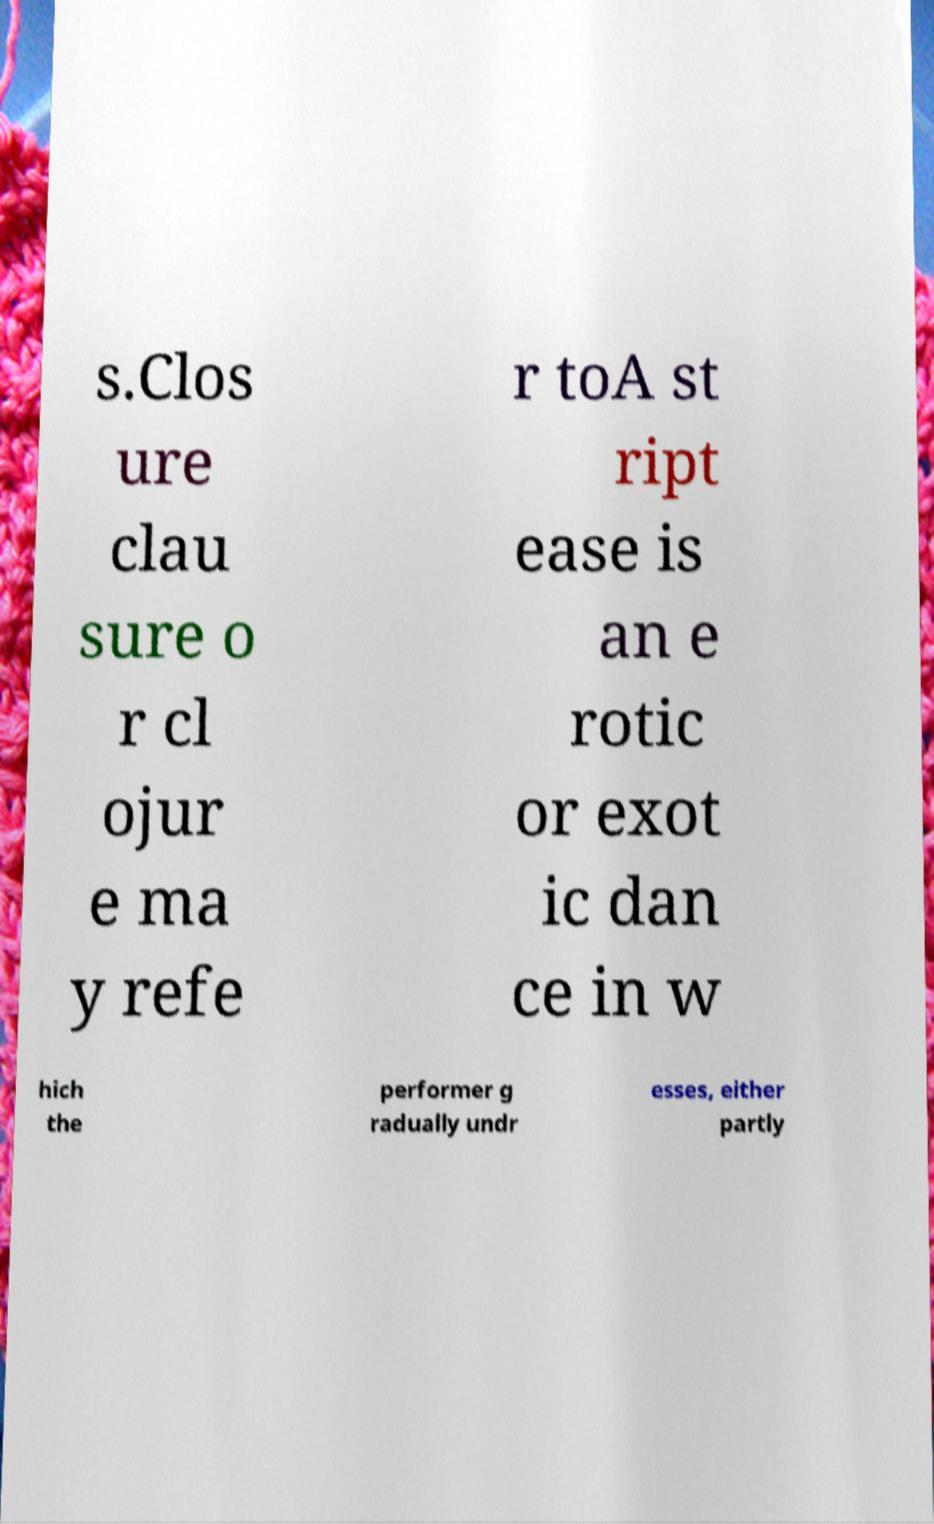I need the written content from this picture converted into text. Can you do that? s.Clos ure clau sure o r cl ojur e ma y refe r toA st ript ease is an e rotic or exot ic dan ce in w hich the performer g radually undr esses, either partly 